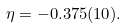Convert formula to latex. <formula><loc_0><loc_0><loc_500><loc_500>\eta = - 0 . 3 7 5 ( 1 0 ) .</formula> 